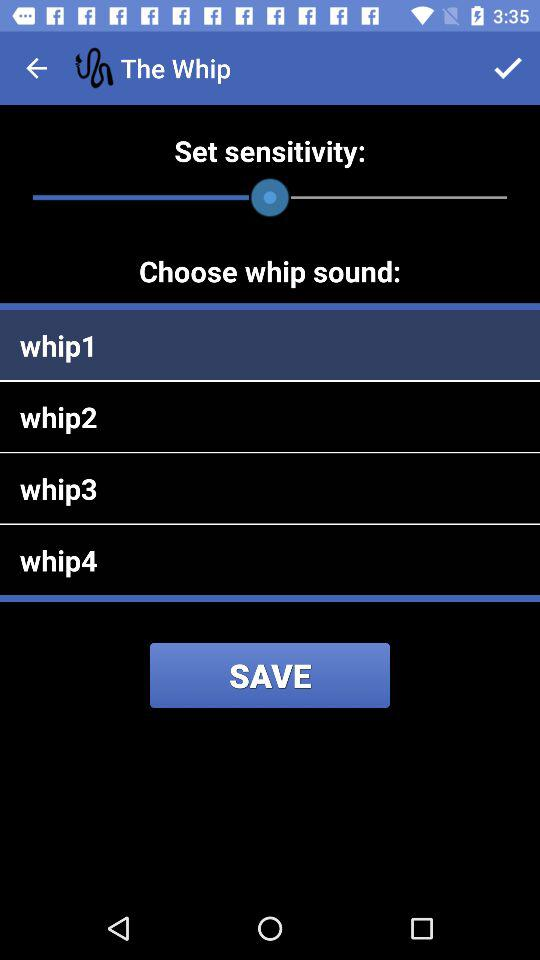How many total whip sounds are there? There are 4 whip sounds. 